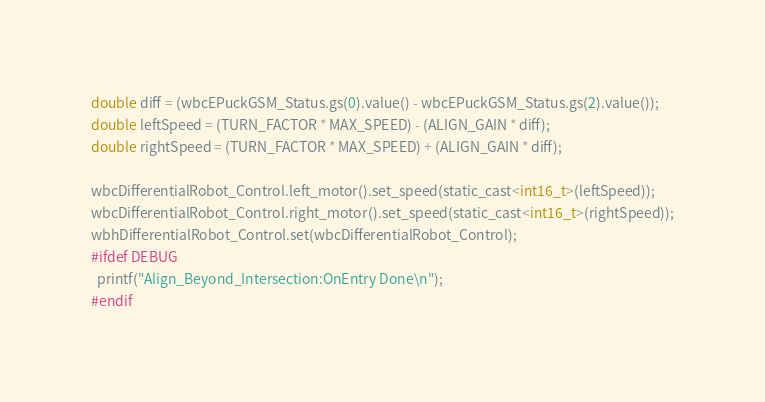<code> <loc_0><loc_0><loc_500><loc_500><_ObjectiveC_>double diff = (wbcEPuckGSM_Status.gs(0).value() - wbcEPuckGSM_Status.gs(2).value());
double leftSpeed = (TURN_FACTOR * MAX_SPEED) - (ALIGN_GAIN * diff);
double rightSpeed = (TURN_FACTOR * MAX_SPEED) + (ALIGN_GAIN * diff);

wbcDifferentialRobot_Control.left_motor().set_speed(static_cast<int16_t>(leftSpeed));
wbcDifferentialRobot_Control.right_motor().set_speed(static_cast<int16_t>(rightSpeed));
wbhDifferentialRobot_Control.set(wbcDifferentialRobot_Control);
#ifdef DEBUG
  printf("Align_Beyond_Intersection:OnEntry Done\n");
#endif
</code> 